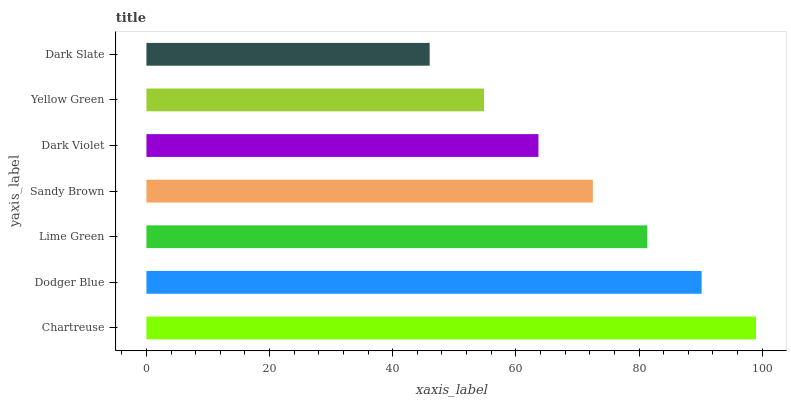Is Dark Slate the minimum?
Answer yes or no. Yes. Is Chartreuse the maximum?
Answer yes or no. Yes. Is Dodger Blue the minimum?
Answer yes or no. No. Is Dodger Blue the maximum?
Answer yes or no. No. Is Chartreuse greater than Dodger Blue?
Answer yes or no. Yes. Is Dodger Blue less than Chartreuse?
Answer yes or no. Yes. Is Dodger Blue greater than Chartreuse?
Answer yes or no. No. Is Chartreuse less than Dodger Blue?
Answer yes or no. No. Is Sandy Brown the high median?
Answer yes or no. Yes. Is Sandy Brown the low median?
Answer yes or no. Yes. Is Dark Slate the high median?
Answer yes or no. No. Is Yellow Green the low median?
Answer yes or no. No. 